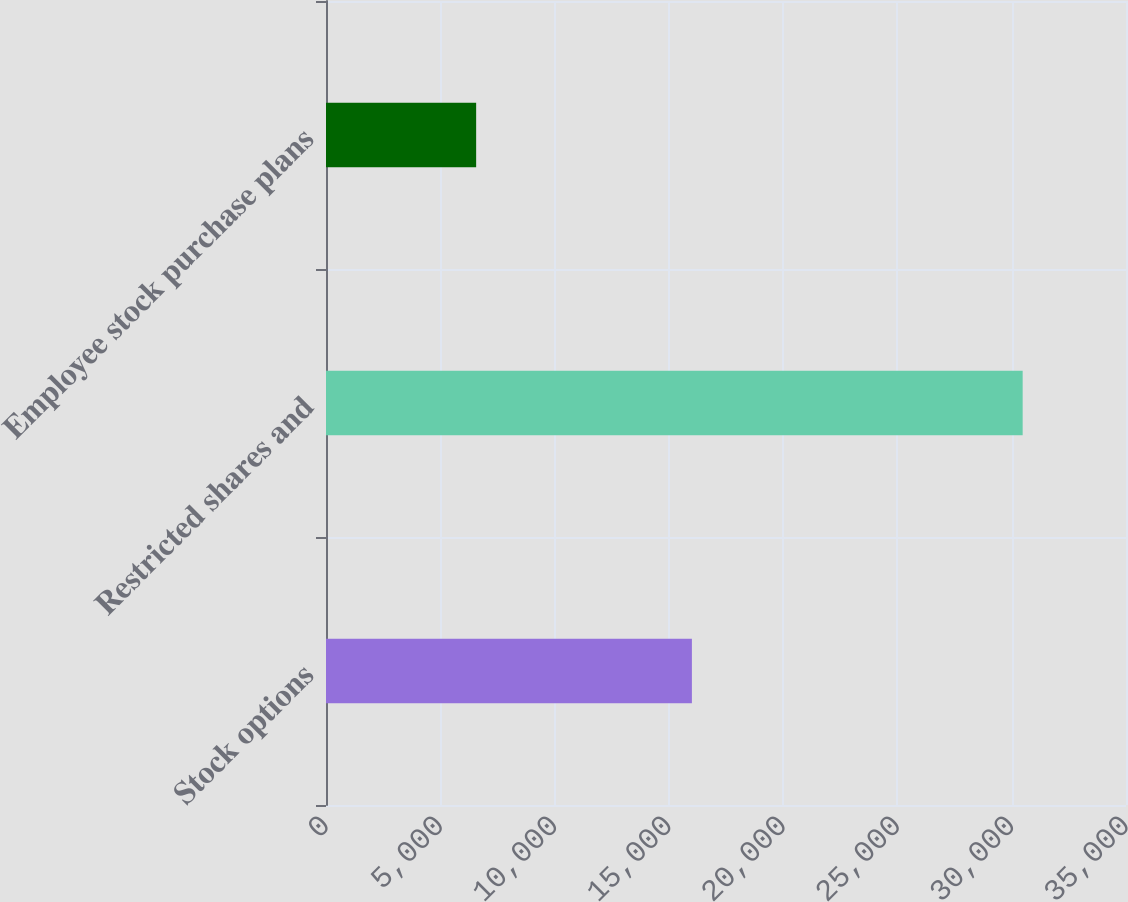Convert chart to OTSL. <chart><loc_0><loc_0><loc_500><loc_500><bar_chart><fcel>Stock options<fcel>Restricted shares and<fcel>Employee stock purchase plans<nl><fcel>16008<fcel>30479<fcel>6569<nl></chart> 